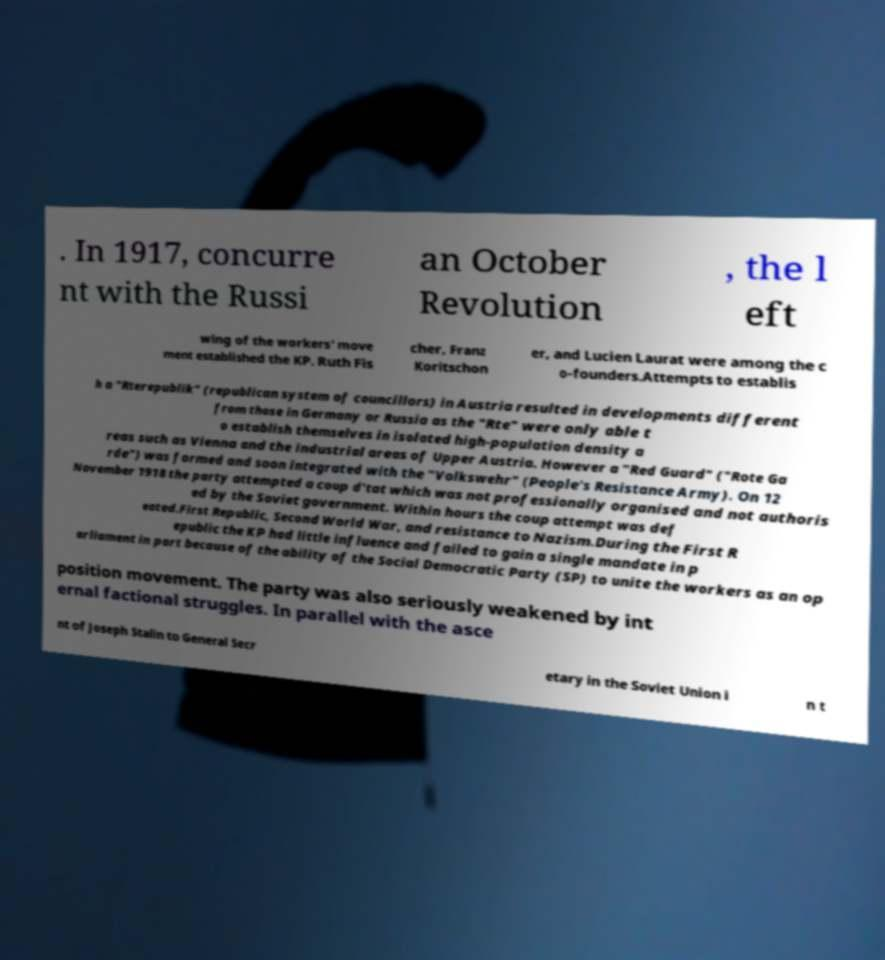Could you extract and type out the text from this image? . In 1917, concurre nt with the Russi an October Revolution , the l eft wing of the workers' move ment established the KP. Ruth Fis cher, Franz Koritschon er, and Lucien Laurat were among the c o-founders.Attempts to establis h a "Rterepublik" (republican system of councillors) in Austria resulted in developments different from those in Germany or Russia as the "Rte" were only able t o establish themselves in isolated high-population density a reas such as Vienna and the industrial areas of Upper Austria. However a "Red Guard" ("Rote Ga rde") was formed and soon integrated with the "Volkswehr" (People's Resistance Army). On 12 November 1918 the party attempted a coup d'tat which was not professionally organised and not authoris ed by the Soviet government. Within hours the coup attempt was def eated.First Republic, Second World War, and resistance to Nazism.During the First R epublic the KP had little influence and failed to gain a single mandate in p arliament in part because of the ability of the Social Democratic Party (SP) to unite the workers as an op position movement. The party was also seriously weakened by int ernal factional struggles. In parallel with the asce nt of Joseph Stalin to General Secr etary in the Soviet Union i n t 